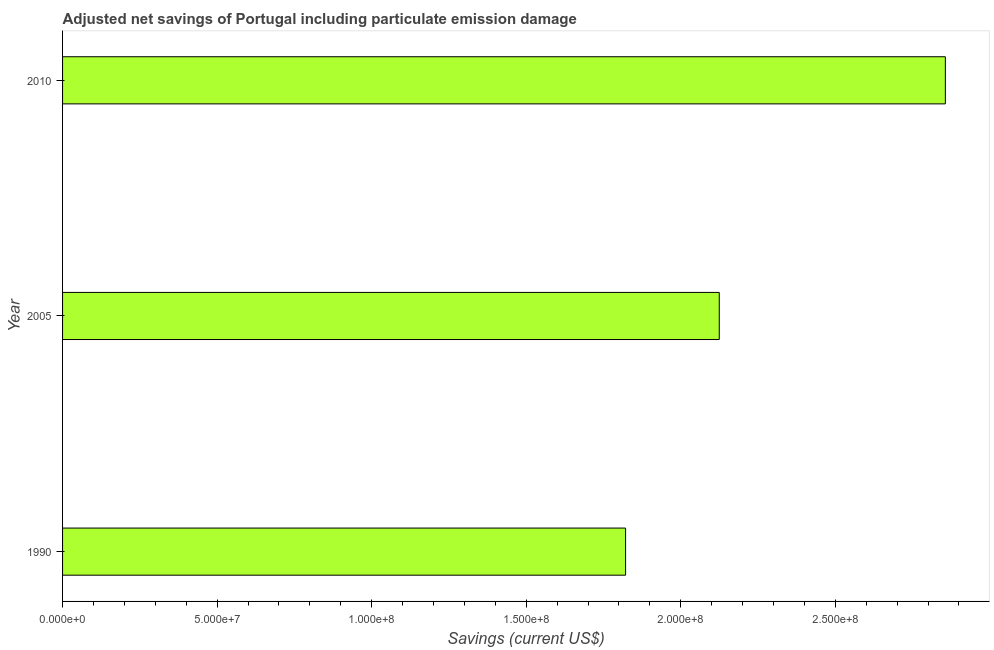What is the title of the graph?
Offer a very short reply. Adjusted net savings of Portugal including particulate emission damage. What is the label or title of the X-axis?
Your answer should be very brief. Savings (current US$). What is the label or title of the Y-axis?
Offer a very short reply. Year. What is the adjusted net savings in 2010?
Keep it short and to the point. 2.86e+08. Across all years, what is the maximum adjusted net savings?
Ensure brevity in your answer.  2.86e+08. Across all years, what is the minimum adjusted net savings?
Keep it short and to the point. 1.82e+08. In which year was the adjusted net savings minimum?
Keep it short and to the point. 1990. What is the sum of the adjusted net savings?
Offer a very short reply. 6.80e+08. What is the difference between the adjusted net savings in 1990 and 2010?
Offer a terse response. -1.03e+08. What is the average adjusted net savings per year?
Offer a terse response. 2.27e+08. What is the median adjusted net savings?
Keep it short and to the point. 2.12e+08. Do a majority of the years between 2010 and 2005 (inclusive) have adjusted net savings greater than 210000000 US$?
Give a very brief answer. No. What is the ratio of the adjusted net savings in 1990 to that in 2010?
Ensure brevity in your answer.  0.64. What is the difference between the highest and the second highest adjusted net savings?
Keep it short and to the point. 7.31e+07. Is the sum of the adjusted net savings in 2005 and 2010 greater than the maximum adjusted net savings across all years?
Provide a short and direct response. Yes. What is the difference between the highest and the lowest adjusted net savings?
Provide a succinct answer. 1.03e+08. How many bars are there?
Give a very brief answer. 3. Are all the bars in the graph horizontal?
Make the answer very short. Yes. How many years are there in the graph?
Your answer should be very brief. 3. What is the Savings (current US$) in 1990?
Your answer should be compact. 1.82e+08. What is the Savings (current US$) in 2005?
Your response must be concise. 2.12e+08. What is the Savings (current US$) of 2010?
Keep it short and to the point. 2.86e+08. What is the difference between the Savings (current US$) in 1990 and 2005?
Ensure brevity in your answer.  -3.03e+07. What is the difference between the Savings (current US$) in 1990 and 2010?
Your answer should be compact. -1.03e+08. What is the difference between the Savings (current US$) in 2005 and 2010?
Provide a short and direct response. -7.31e+07. What is the ratio of the Savings (current US$) in 1990 to that in 2005?
Provide a short and direct response. 0.86. What is the ratio of the Savings (current US$) in 1990 to that in 2010?
Provide a short and direct response. 0.64. What is the ratio of the Savings (current US$) in 2005 to that in 2010?
Your answer should be very brief. 0.74. 